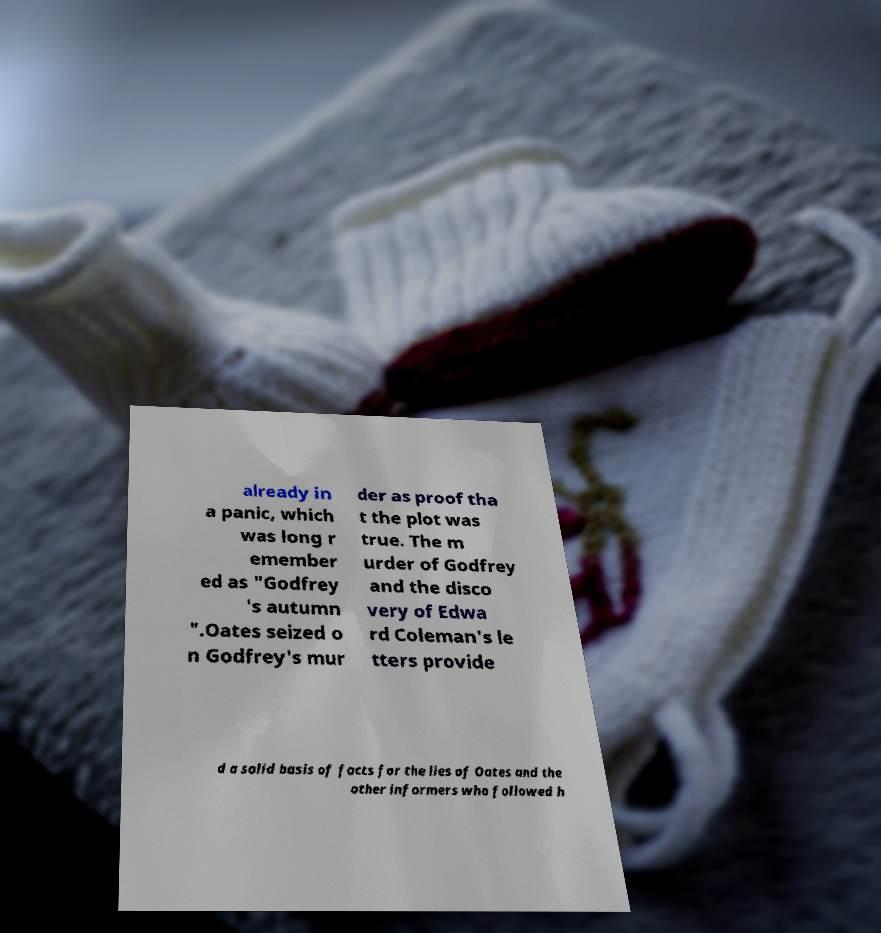I need the written content from this picture converted into text. Can you do that? already in a panic, which was long r emember ed as "Godfrey 's autumn ".Oates seized o n Godfrey's mur der as proof tha t the plot was true. The m urder of Godfrey and the disco very of Edwa rd Coleman's le tters provide d a solid basis of facts for the lies of Oates and the other informers who followed h 